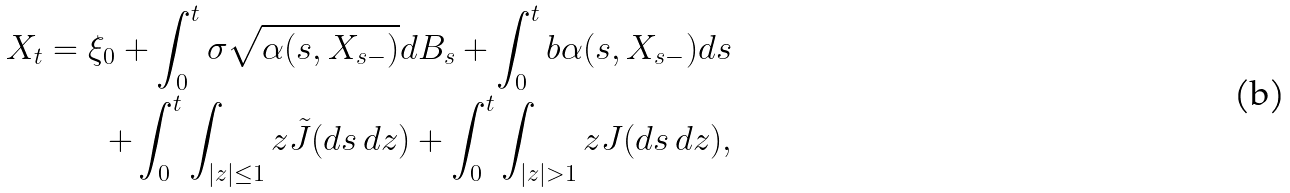<formula> <loc_0><loc_0><loc_500><loc_500>X _ { t } = \xi _ { 0 } + \int _ { 0 } ^ { t } \sigma \sqrt { \alpha ( s , X _ { s - } ) } d B _ { s } + \int _ { 0 } ^ { t } b \alpha ( s , X _ { s - } ) d s \\ + \int _ { 0 } ^ { t } \int _ { | z | \leq 1 } z \tilde { J } ( d s \, d z ) + \int _ { 0 } ^ { t } \int _ { | z | > 1 } z J ( d s \, d z ) ,</formula> 